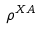Convert formula to latex. <formula><loc_0><loc_0><loc_500><loc_500>\rho ^ { X A }</formula> 